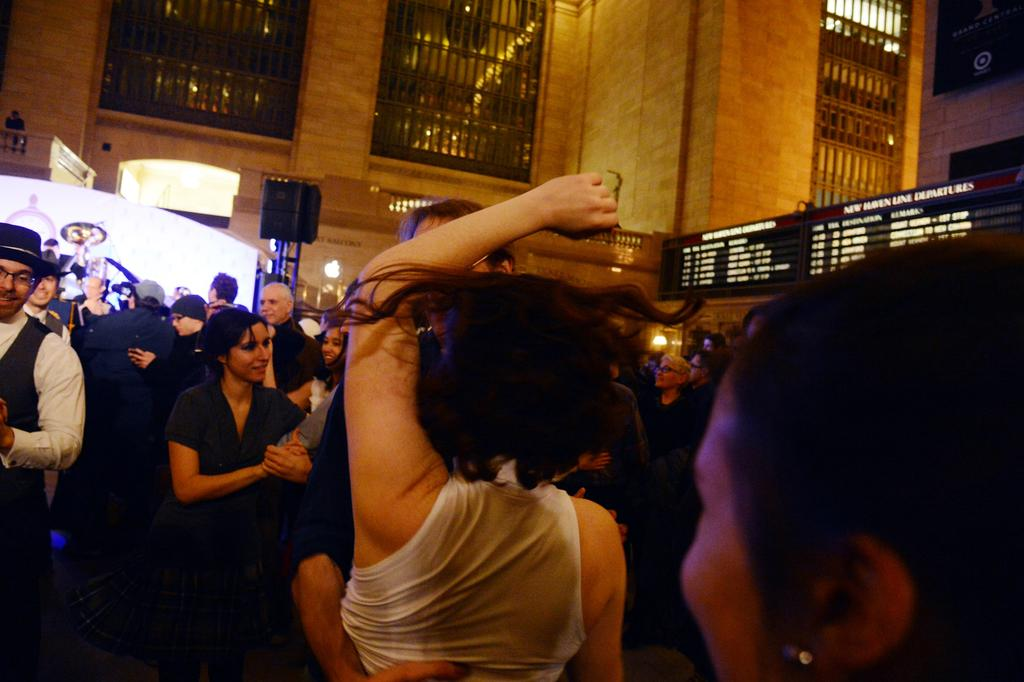What are the persons in the image doing? The persons in the image are standing and dancing. Can you describe the background of the image? There is a building in the background of the image. How many snails can be seen crawling on the wrist of the person in the image? There are no snails present in the image, and no person's wrist is visible. What type of deer is visible in the background of the image? There are no deer present in the image; only a building is visible in the background. 